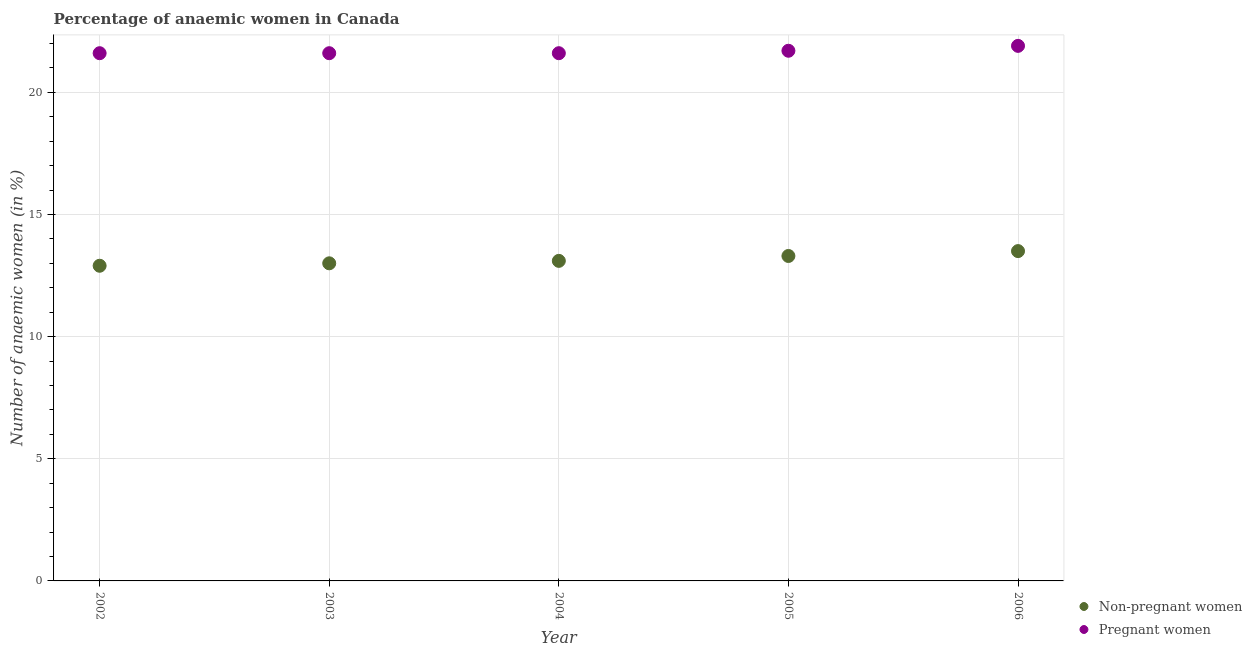Across all years, what is the maximum percentage of non-pregnant anaemic women?
Offer a very short reply. 13.5. Across all years, what is the minimum percentage of pregnant anaemic women?
Provide a succinct answer. 21.6. In which year was the percentage of pregnant anaemic women minimum?
Your answer should be very brief. 2002. What is the total percentage of pregnant anaemic women in the graph?
Make the answer very short. 108.4. What is the difference between the percentage of pregnant anaemic women in 2005 and that in 2006?
Give a very brief answer. -0.2. What is the average percentage of pregnant anaemic women per year?
Offer a terse response. 21.68. In the year 2003, what is the difference between the percentage of pregnant anaemic women and percentage of non-pregnant anaemic women?
Give a very brief answer. 8.6. In how many years, is the percentage of non-pregnant anaemic women greater than 12 %?
Your answer should be compact. 5. What is the difference between the highest and the second highest percentage of non-pregnant anaemic women?
Offer a very short reply. 0.2. What is the difference between the highest and the lowest percentage of non-pregnant anaemic women?
Your response must be concise. 0.6. Is the sum of the percentage of non-pregnant anaemic women in 2005 and 2006 greater than the maximum percentage of pregnant anaemic women across all years?
Offer a very short reply. Yes. Is the percentage of pregnant anaemic women strictly greater than the percentage of non-pregnant anaemic women over the years?
Your answer should be very brief. Yes. How many years are there in the graph?
Offer a terse response. 5. Does the graph contain any zero values?
Provide a succinct answer. No. Where does the legend appear in the graph?
Your answer should be compact. Bottom right. How are the legend labels stacked?
Provide a short and direct response. Vertical. What is the title of the graph?
Keep it short and to the point. Percentage of anaemic women in Canada. What is the label or title of the Y-axis?
Your answer should be compact. Number of anaemic women (in %). What is the Number of anaemic women (in %) in Pregnant women in 2002?
Give a very brief answer. 21.6. What is the Number of anaemic women (in %) of Non-pregnant women in 2003?
Offer a terse response. 13. What is the Number of anaemic women (in %) in Pregnant women in 2003?
Your response must be concise. 21.6. What is the Number of anaemic women (in %) in Non-pregnant women in 2004?
Your answer should be very brief. 13.1. What is the Number of anaemic women (in %) of Pregnant women in 2004?
Provide a succinct answer. 21.6. What is the Number of anaemic women (in %) of Non-pregnant women in 2005?
Make the answer very short. 13.3. What is the Number of anaemic women (in %) in Pregnant women in 2005?
Provide a short and direct response. 21.7. What is the Number of anaemic women (in %) in Non-pregnant women in 2006?
Make the answer very short. 13.5. What is the Number of anaemic women (in %) of Pregnant women in 2006?
Make the answer very short. 21.9. Across all years, what is the maximum Number of anaemic women (in %) of Non-pregnant women?
Provide a succinct answer. 13.5. Across all years, what is the maximum Number of anaemic women (in %) of Pregnant women?
Your answer should be compact. 21.9. Across all years, what is the minimum Number of anaemic women (in %) in Pregnant women?
Your answer should be compact. 21.6. What is the total Number of anaemic women (in %) of Non-pregnant women in the graph?
Ensure brevity in your answer.  65.8. What is the total Number of anaemic women (in %) in Pregnant women in the graph?
Give a very brief answer. 108.4. What is the difference between the Number of anaemic women (in %) in Pregnant women in 2002 and that in 2003?
Offer a very short reply. 0. What is the difference between the Number of anaemic women (in %) in Pregnant women in 2002 and that in 2005?
Your answer should be compact. -0.1. What is the difference between the Number of anaemic women (in %) in Pregnant women in 2002 and that in 2006?
Your answer should be very brief. -0.3. What is the difference between the Number of anaemic women (in %) of Pregnant women in 2003 and that in 2004?
Offer a terse response. 0. What is the difference between the Number of anaemic women (in %) of Non-pregnant women in 2003 and that in 2005?
Your answer should be compact. -0.3. What is the difference between the Number of anaemic women (in %) in Non-pregnant women in 2004 and that in 2005?
Offer a very short reply. -0.2. What is the difference between the Number of anaemic women (in %) of Non-pregnant women in 2004 and that in 2006?
Make the answer very short. -0.4. What is the difference between the Number of anaemic women (in %) in Non-pregnant women in 2005 and that in 2006?
Your answer should be very brief. -0.2. What is the difference between the Number of anaemic women (in %) in Non-pregnant women in 2002 and the Number of anaemic women (in %) in Pregnant women in 2004?
Your answer should be very brief. -8.7. What is the difference between the Number of anaemic women (in %) in Non-pregnant women in 2003 and the Number of anaemic women (in %) in Pregnant women in 2004?
Give a very brief answer. -8.6. What is the difference between the Number of anaemic women (in %) in Non-pregnant women in 2003 and the Number of anaemic women (in %) in Pregnant women in 2005?
Your response must be concise. -8.7. What is the difference between the Number of anaemic women (in %) in Non-pregnant women in 2003 and the Number of anaemic women (in %) in Pregnant women in 2006?
Your answer should be compact. -8.9. What is the difference between the Number of anaemic women (in %) in Non-pregnant women in 2004 and the Number of anaemic women (in %) in Pregnant women in 2005?
Your response must be concise. -8.6. What is the difference between the Number of anaemic women (in %) of Non-pregnant women in 2005 and the Number of anaemic women (in %) of Pregnant women in 2006?
Offer a very short reply. -8.6. What is the average Number of anaemic women (in %) in Non-pregnant women per year?
Ensure brevity in your answer.  13.16. What is the average Number of anaemic women (in %) in Pregnant women per year?
Ensure brevity in your answer.  21.68. In the year 2002, what is the difference between the Number of anaemic women (in %) in Non-pregnant women and Number of anaemic women (in %) in Pregnant women?
Provide a short and direct response. -8.7. In the year 2003, what is the difference between the Number of anaemic women (in %) in Non-pregnant women and Number of anaemic women (in %) in Pregnant women?
Provide a succinct answer. -8.6. In the year 2005, what is the difference between the Number of anaemic women (in %) in Non-pregnant women and Number of anaemic women (in %) in Pregnant women?
Offer a very short reply. -8.4. In the year 2006, what is the difference between the Number of anaemic women (in %) in Non-pregnant women and Number of anaemic women (in %) in Pregnant women?
Offer a terse response. -8.4. What is the ratio of the Number of anaemic women (in %) in Non-pregnant women in 2002 to that in 2004?
Provide a succinct answer. 0.98. What is the ratio of the Number of anaemic women (in %) in Pregnant women in 2002 to that in 2004?
Make the answer very short. 1. What is the ratio of the Number of anaemic women (in %) of Non-pregnant women in 2002 to that in 2005?
Your answer should be very brief. 0.97. What is the ratio of the Number of anaemic women (in %) of Non-pregnant women in 2002 to that in 2006?
Make the answer very short. 0.96. What is the ratio of the Number of anaemic women (in %) of Pregnant women in 2002 to that in 2006?
Make the answer very short. 0.99. What is the ratio of the Number of anaemic women (in %) in Pregnant women in 2003 to that in 2004?
Your answer should be very brief. 1. What is the ratio of the Number of anaemic women (in %) in Non-pregnant women in 2003 to that in 2005?
Ensure brevity in your answer.  0.98. What is the ratio of the Number of anaemic women (in %) of Pregnant women in 2003 to that in 2005?
Your answer should be very brief. 1. What is the ratio of the Number of anaemic women (in %) in Pregnant women in 2003 to that in 2006?
Your response must be concise. 0.99. What is the ratio of the Number of anaemic women (in %) in Non-pregnant women in 2004 to that in 2006?
Make the answer very short. 0.97. What is the ratio of the Number of anaemic women (in %) of Pregnant women in 2004 to that in 2006?
Your answer should be compact. 0.99. What is the ratio of the Number of anaemic women (in %) of Non-pregnant women in 2005 to that in 2006?
Keep it short and to the point. 0.99. What is the ratio of the Number of anaemic women (in %) in Pregnant women in 2005 to that in 2006?
Make the answer very short. 0.99. What is the difference between the highest and the second highest Number of anaemic women (in %) in Non-pregnant women?
Keep it short and to the point. 0.2. What is the difference between the highest and the lowest Number of anaemic women (in %) in Pregnant women?
Give a very brief answer. 0.3. 